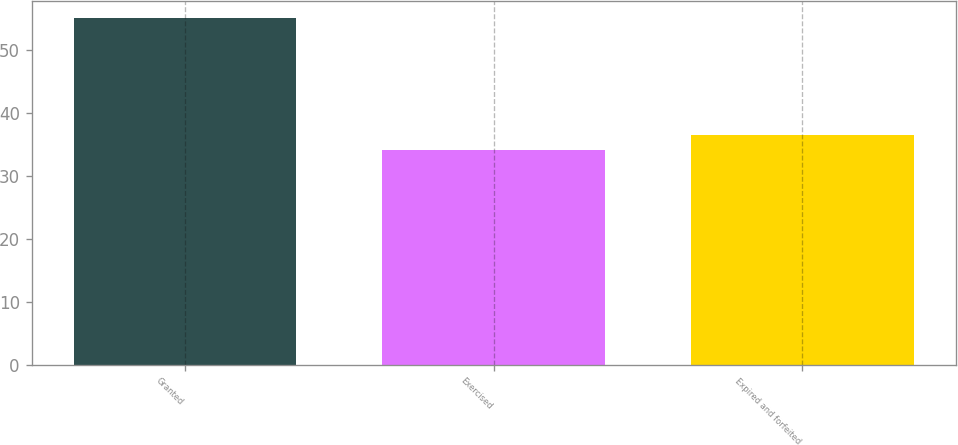Convert chart to OTSL. <chart><loc_0><loc_0><loc_500><loc_500><bar_chart><fcel>Granted<fcel>Exercised<fcel>Expired and forfeited<nl><fcel>55.11<fcel>34.2<fcel>36.51<nl></chart> 